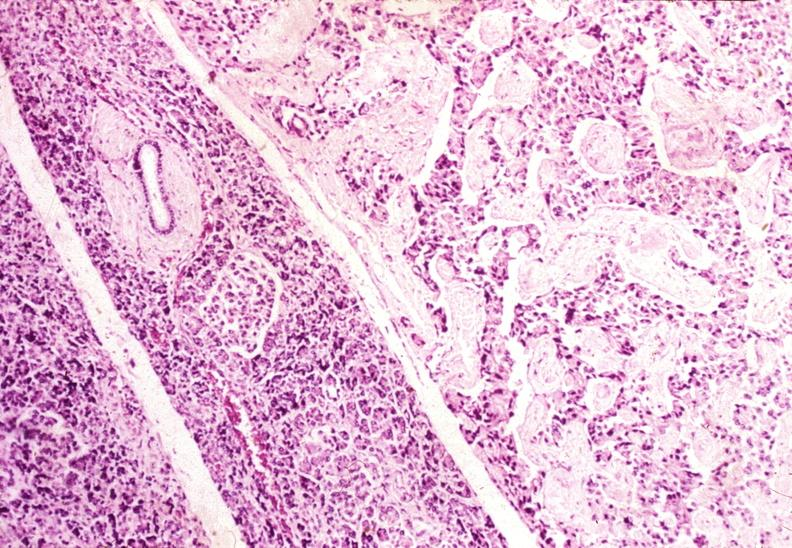what does this image show?
Answer the question using a single word or phrase. Islet cell carcinoma 